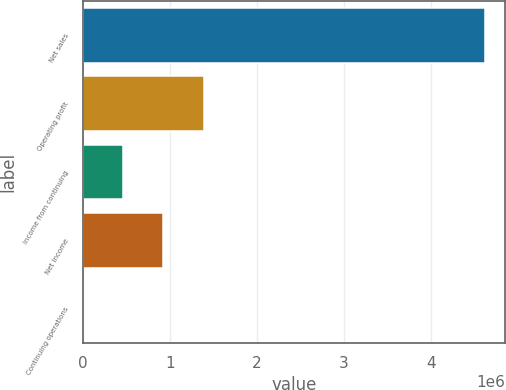Convert chart. <chart><loc_0><loc_0><loc_500><loc_500><bar_chart><fcel>Net sales<fcel>Operating profit<fcel>Income from continuing<fcel>Net income<fcel>Continuing operations<nl><fcel>4.6278e+06<fcel>1.38834e+06<fcel>462783<fcel>925563<fcel>3.31<nl></chart> 